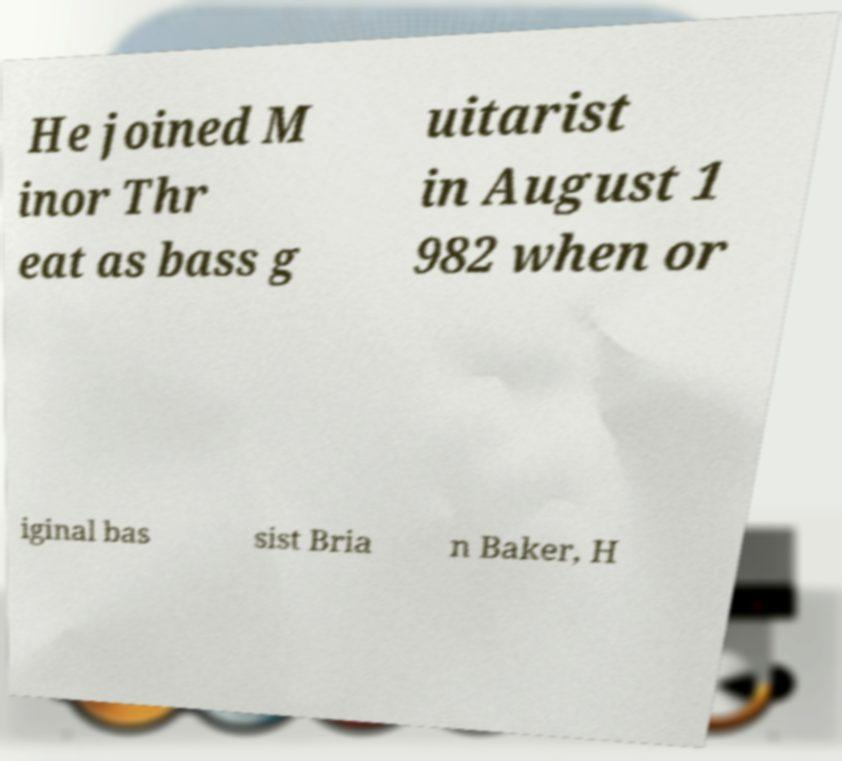Can you read and provide the text displayed in the image?This photo seems to have some interesting text. Can you extract and type it out for me? He joined M inor Thr eat as bass g uitarist in August 1 982 when or iginal bas sist Bria n Baker, H 